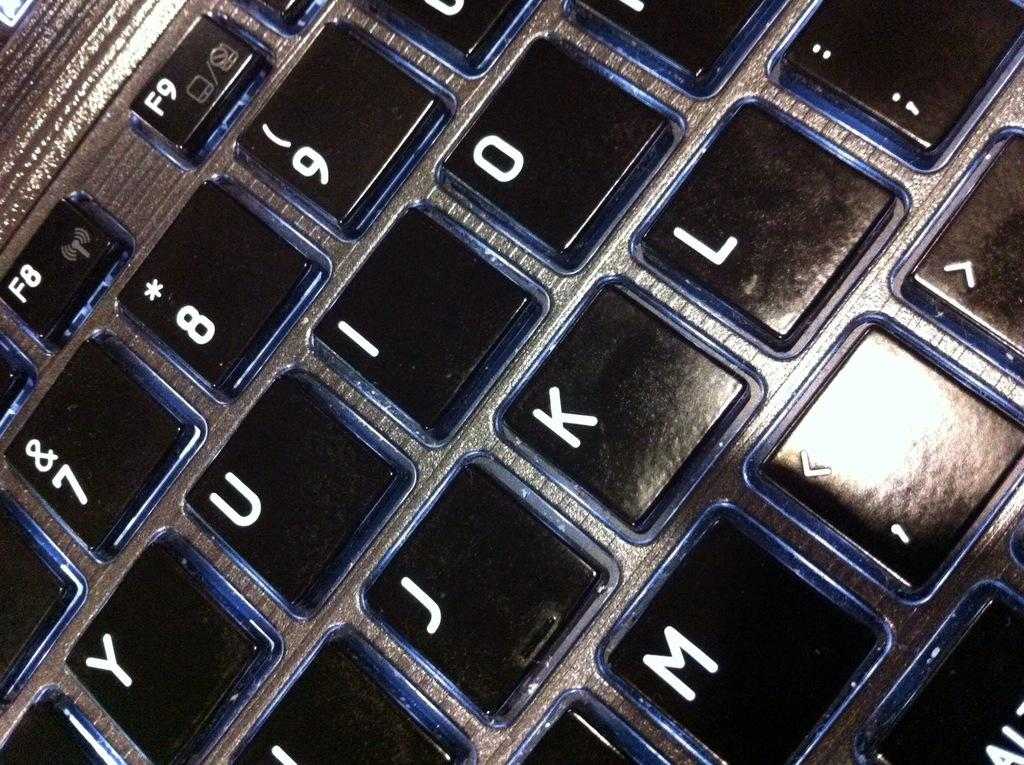<image>
Present a compact description of the photo's key features. A keyboard with the letters J K and L is seen 